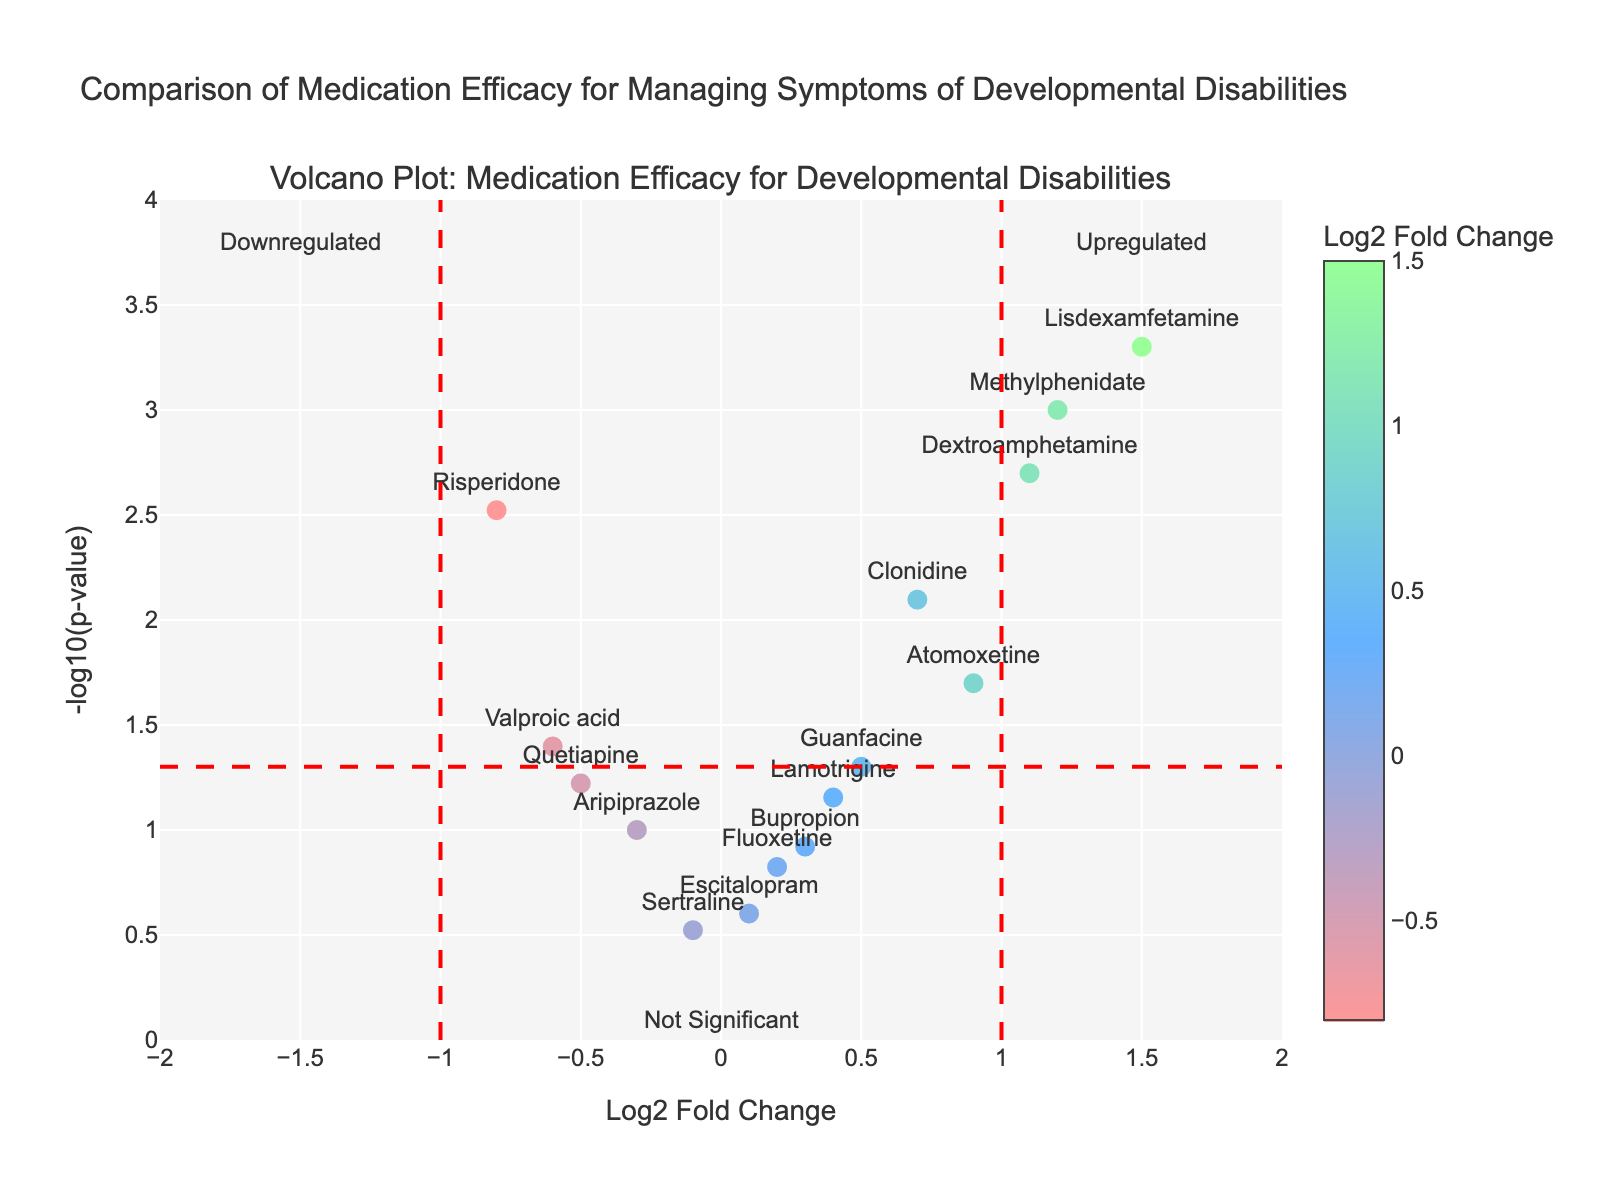What does the title of the figure indicate? The title of the figure, "Comparison of Medication Efficacy for Managing Symptoms of Developmental Disabilities," indicates that the plot compares the effectiveness of different medications in managing symptoms of developmental disabilities.
Answer: It compares medication efficacy for managing symptoms of developmental disabilities What does the y-axis represent? The y-axis represents the -log10 of the p-value, which signifies the statistical significance of the results. Higher y-values indicate more significant results.
Answer: -log10(p-value) Which drug has the highest Log2 Fold Change? Look at the x-axis, which represents Log2 Fold Change. The drug with the highest value is positioned farthest to the right. Lisdexamfetamine has the highest Log2 Fold Change of 1.5.
Answer: Lisdexamfetamine Which drug has the lowest P-value? Look at the points highest on the y-axis since -log10(p-value) is higher for lower p-values. Lisdexamfetamine, with a p-value of 0.0005, is positioned at the highest point.
Answer: Lisdexamfetamine How many drugs have a Log2 Fold Change greater than 1? Identify the markers to the right of the x=1 line. These drugs are Methylphenidate, Lisdexamfetamine, and Dextroamphetamine. There are three drugs meeting this criterion.
Answer: 3 Which drugs are significantly upregulated? Significant upregulation indicates drugs with a Log2 Fold Change greater than 1 and a p-value less than 0.05 (y values above the horizontal threshold line). Methylphenidate, Lisdexamfetamine, and Dextroamphetamine meet these criteria.
Answer: Methylphenidate, Lisdexamfetamine, Dextroamphetamine What does the color of the markers signify? The color of the markers represents the Log2 Fold Change of the drugs. A custom color scale is used where different colors indicate different levels of fold change.
Answer: Log2 Fold Change Which drug is marked as downregulated most significantly? Look for drugs with the highest -log10(p-value) on the left side of the x-axis (negative Log2 Fold Change). Risperidone is the most significantly downregulated with a Log2 Fold Change of -0.8 and a low p-value.
Answer: Risperidone How does the significance of Aripiprazole compare to Methylphenidate? Compare their vertical positions. Methylphenidate is higher on the y-axis (-log10(p-value)) than Aripiprazole, indicating it is more statistically significant.
Answer: Methylphenidate is more significant What can you say about the efficacy and side effects of Valproic acid? Valproic acid has a negative Log2 Fold Change (-0.6) indicating it may reduce symptoms. However, it is positioned below the horizontal significance threshold, indicating its effects are not statistically significant.
Answer: Efficacy not statistically significant, might reduce symptoms 